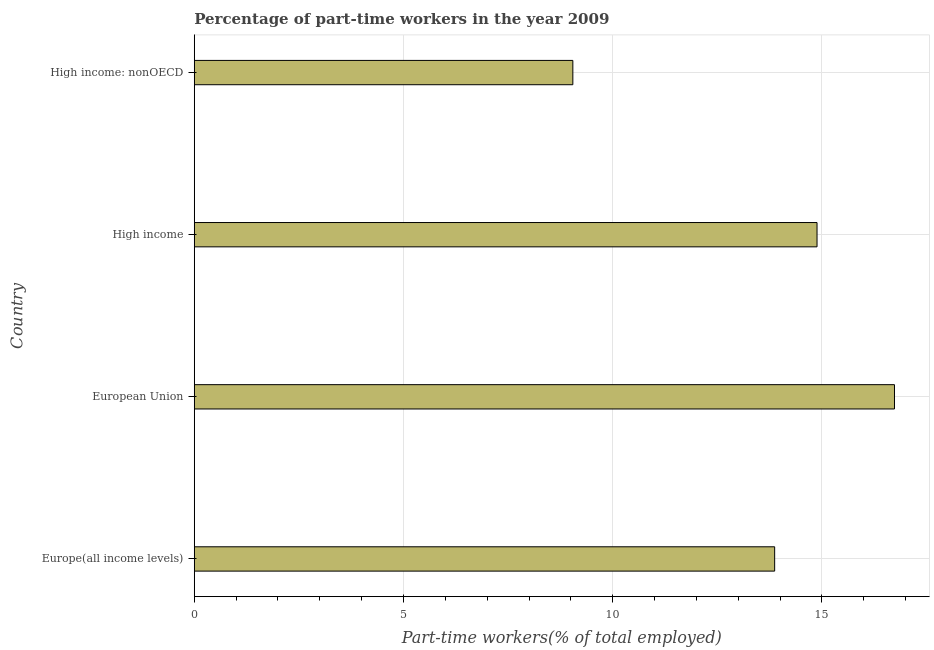Does the graph contain any zero values?
Your answer should be compact. No. Does the graph contain grids?
Offer a terse response. Yes. What is the title of the graph?
Ensure brevity in your answer.  Percentage of part-time workers in the year 2009. What is the label or title of the X-axis?
Your response must be concise. Part-time workers(% of total employed). What is the percentage of part-time workers in European Union?
Your response must be concise. 16.73. Across all countries, what is the maximum percentage of part-time workers?
Provide a succinct answer. 16.73. Across all countries, what is the minimum percentage of part-time workers?
Offer a terse response. 9.05. In which country was the percentage of part-time workers minimum?
Offer a very short reply. High income: nonOECD. What is the sum of the percentage of part-time workers?
Give a very brief answer. 54.53. What is the difference between the percentage of part-time workers in High income and High income: nonOECD?
Make the answer very short. 5.83. What is the average percentage of part-time workers per country?
Keep it short and to the point. 13.63. What is the median percentage of part-time workers?
Your answer should be very brief. 14.38. What is the ratio of the percentage of part-time workers in European Union to that in High income: nonOECD?
Your answer should be very brief. 1.85. Is the difference between the percentage of part-time workers in Europe(all income levels) and European Union greater than the difference between any two countries?
Ensure brevity in your answer.  No. What is the difference between the highest and the second highest percentage of part-time workers?
Give a very brief answer. 1.85. Is the sum of the percentage of part-time workers in European Union and High income greater than the maximum percentage of part-time workers across all countries?
Offer a terse response. Yes. What is the difference between the highest and the lowest percentage of part-time workers?
Your response must be concise. 7.69. How many bars are there?
Offer a terse response. 4. What is the difference between two consecutive major ticks on the X-axis?
Offer a terse response. 5. Are the values on the major ticks of X-axis written in scientific E-notation?
Your answer should be compact. No. What is the Part-time workers(% of total employed) in Europe(all income levels)?
Ensure brevity in your answer.  13.87. What is the Part-time workers(% of total employed) of European Union?
Ensure brevity in your answer.  16.73. What is the Part-time workers(% of total employed) of High income?
Offer a terse response. 14.88. What is the Part-time workers(% of total employed) in High income: nonOECD?
Provide a succinct answer. 9.05. What is the difference between the Part-time workers(% of total employed) in Europe(all income levels) and European Union?
Give a very brief answer. -2.86. What is the difference between the Part-time workers(% of total employed) in Europe(all income levels) and High income?
Keep it short and to the point. -1.01. What is the difference between the Part-time workers(% of total employed) in Europe(all income levels) and High income: nonOECD?
Keep it short and to the point. 4.82. What is the difference between the Part-time workers(% of total employed) in European Union and High income?
Ensure brevity in your answer.  1.85. What is the difference between the Part-time workers(% of total employed) in European Union and High income: nonOECD?
Your response must be concise. 7.69. What is the difference between the Part-time workers(% of total employed) in High income and High income: nonOECD?
Your response must be concise. 5.84. What is the ratio of the Part-time workers(% of total employed) in Europe(all income levels) to that in European Union?
Make the answer very short. 0.83. What is the ratio of the Part-time workers(% of total employed) in Europe(all income levels) to that in High income?
Your answer should be very brief. 0.93. What is the ratio of the Part-time workers(% of total employed) in Europe(all income levels) to that in High income: nonOECD?
Keep it short and to the point. 1.53. What is the ratio of the Part-time workers(% of total employed) in European Union to that in High income?
Make the answer very short. 1.12. What is the ratio of the Part-time workers(% of total employed) in European Union to that in High income: nonOECD?
Ensure brevity in your answer.  1.85. What is the ratio of the Part-time workers(% of total employed) in High income to that in High income: nonOECD?
Make the answer very short. 1.65. 